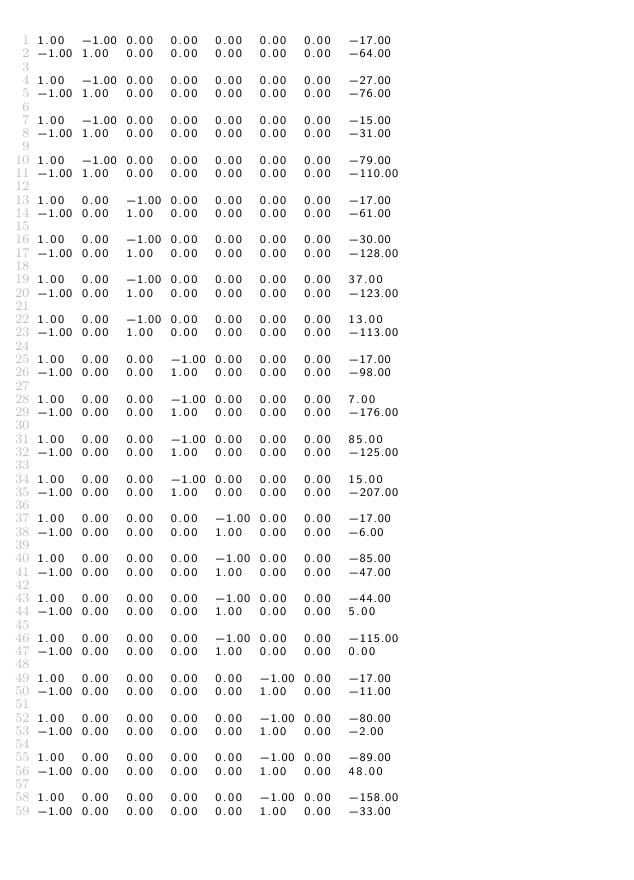Convert code to text. <code><loc_0><loc_0><loc_500><loc_500><_Matlab_>1.00	-1.00	0.00	0.00	0.00	0.00	0.00	-17.00
-1.00	1.00	0.00	0.00	0.00	0.00	0.00	-64.00

1.00	-1.00	0.00	0.00	0.00	0.00	0.00	-27.00
-1.00	1.00	0.00	0.00	0.00	0.00	0.00	-76.00

1.00	-1.00	0.00	0.00	0.00	0.00	0.00	-15.00
-1.00	1.00	0.00	0.00	0.00	0.00	0.00	-31.00

1.00	-1.00	0.00	0.00	0.00	0.00	0.00	-79.00
-1.00	1.00	0.00	0.00	0.00	0.00	0.00	-110.00

1.00	0.00	-1.00	0.00	0.00	0.00	0.00	-17.00
-1.00	0.00	1.00	0.00	0.00	0.00	0.00	-61.00

1.00	0.00	-1.00	0.00	0.00	0.00	0.00	-30.00
-1.00	0.00	1.00	0.00	0.00	0.00	0.00	-128.00

1.00	0.00	-1.00	0.00	0.00	0.00	0.00	37.00
-1.00	0.00	1.00	0.00	0.00	0.00	0.00	-123.00

1.00	0.00	-1.00	0.00	0.00	0.00	0.00	13.00
-1.00	0.00	1.00	0.00	0.00	0.00	0.00	-113.00

1.00	0.00	0.00	-1.00	0.00	0.00	0.00	-17.00
-1.00	0.00	0.00	1.00	0.00	0.00	0.00	-98.00

1.00	0.00	0.00	-1.00	0.00	0.00	0.00	7.00
-1.00	0.00	0.00	1.00	0.00	0.00	0.00	-176.00

1.00	0.00	0.00	-1.00	0.00	0.00	0.00	85.00
-1.00	0.00	0.00	1.00	0.00	0.00	0.00	-125.00

1.00	0.00	0.00	-1.00	0.00	0.00	0.00	15.00
-1.00	0.00	0.00	1.00	0.00	0.00	0.00	-207.00

1.00	0.00	0.00	0.00	-1.00	0.00	0.00	-17.00
-1.00	0.00	0.00	0.00	1.00	0.00	0.00	-6.00

1.00	0.00	0.00	0.00	-1.00	0.00	0.00	-85.00
-1.00	0.00	0.00	0.00	1.00	0.00	0.00	-47.00

1.00	0.00	0.00	0.00	-1.00	0.00	0.00	-44.00
-1.00	0.00	0.00	0.00	1.00	0.00	0.00	5.00

1.00	0.00	0.00	0.00	-1.00	0.00	0.00	-115.00
-1.00	0.00	0.00	0.00	1.00	0.00	0.00	0.00

1.00	0.00	0.00	0.00	0.00	-1.00	0.00	-17.00
-1.00	0.00	0.00	0.00	0.00	1.00	0.00	-11.00

1.00	0.00	0.00	0.00	0.00	-1.00	0.00	-80.00
-1.00	0.00	0.00	0.00	0.00	1.00	0.00	-2.00

1.00	0.00	0.00	0.00	0.00	-1.00	0.00	-89.00
-1.00	0.00	0.00	0.00	0.00	1.00	0.00	48.00

1.00	0.00	0.00	0.00	0.00	-1.00	0.00	-158.00
-1.00	0.00	0.00	0.00	0.00	1.00	0.00	-33.00
</code> 